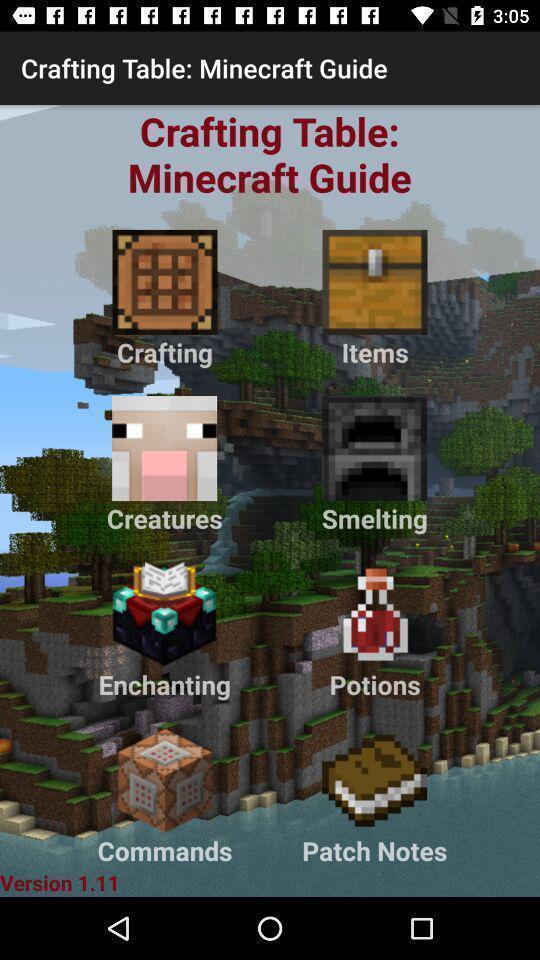Provide a textual representation of this image. Page of a game app. 